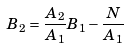Convert formula to latex. <formula><loc_0><loc_0><loc_500><loc_500>B _ { 2 } = \frac { A _ { 2 } } { A _ { 1 } } B _ { 1 } - \frac { N } { A _ { 1 } }</formula> 